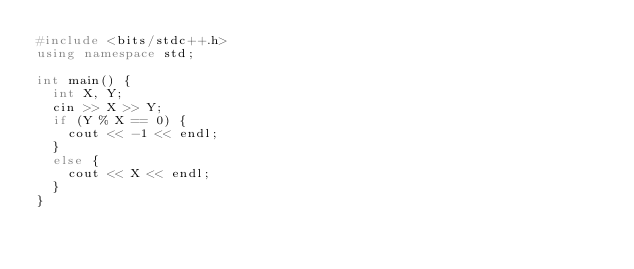<code> <loc_0><loc_0><loc_500><loc_500><_C++_>#include <bits/stdc++.h>
using namespace std;

int main() {
	int X, Y;
	cin >> X >> Y;
	if (Y % X == 0) {
		cout << -1 << endl;
	}
	else {
		cout << X << endl;
	}
}
</code> 